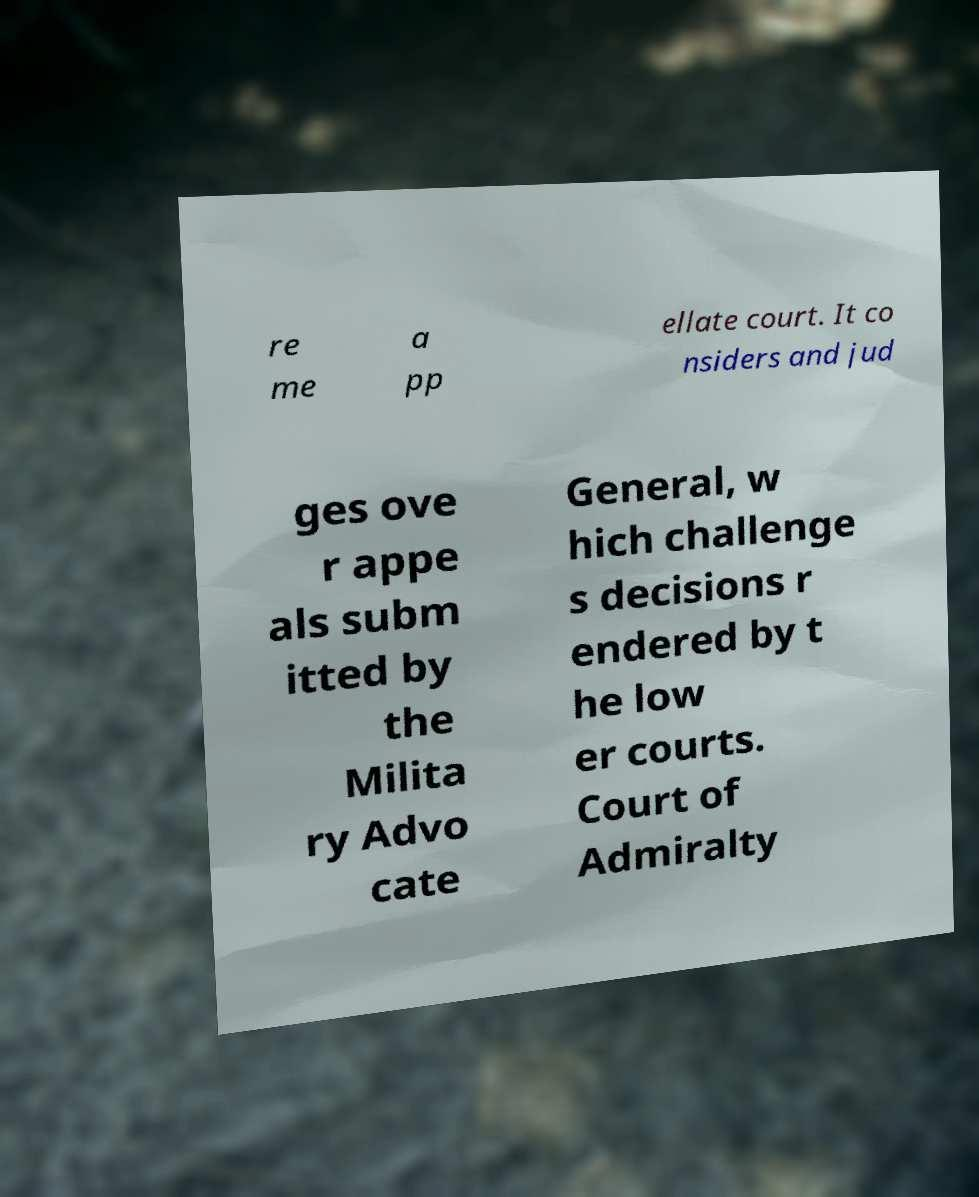Please identify and transcribe the text found in this image. re me a pp ellate court. It co nsiders and jud ges ove r appe als subm itted by the Milita ry Advo cate General, w hich challenge s decisions r endered by t he low er courts. Court of Admiralty 